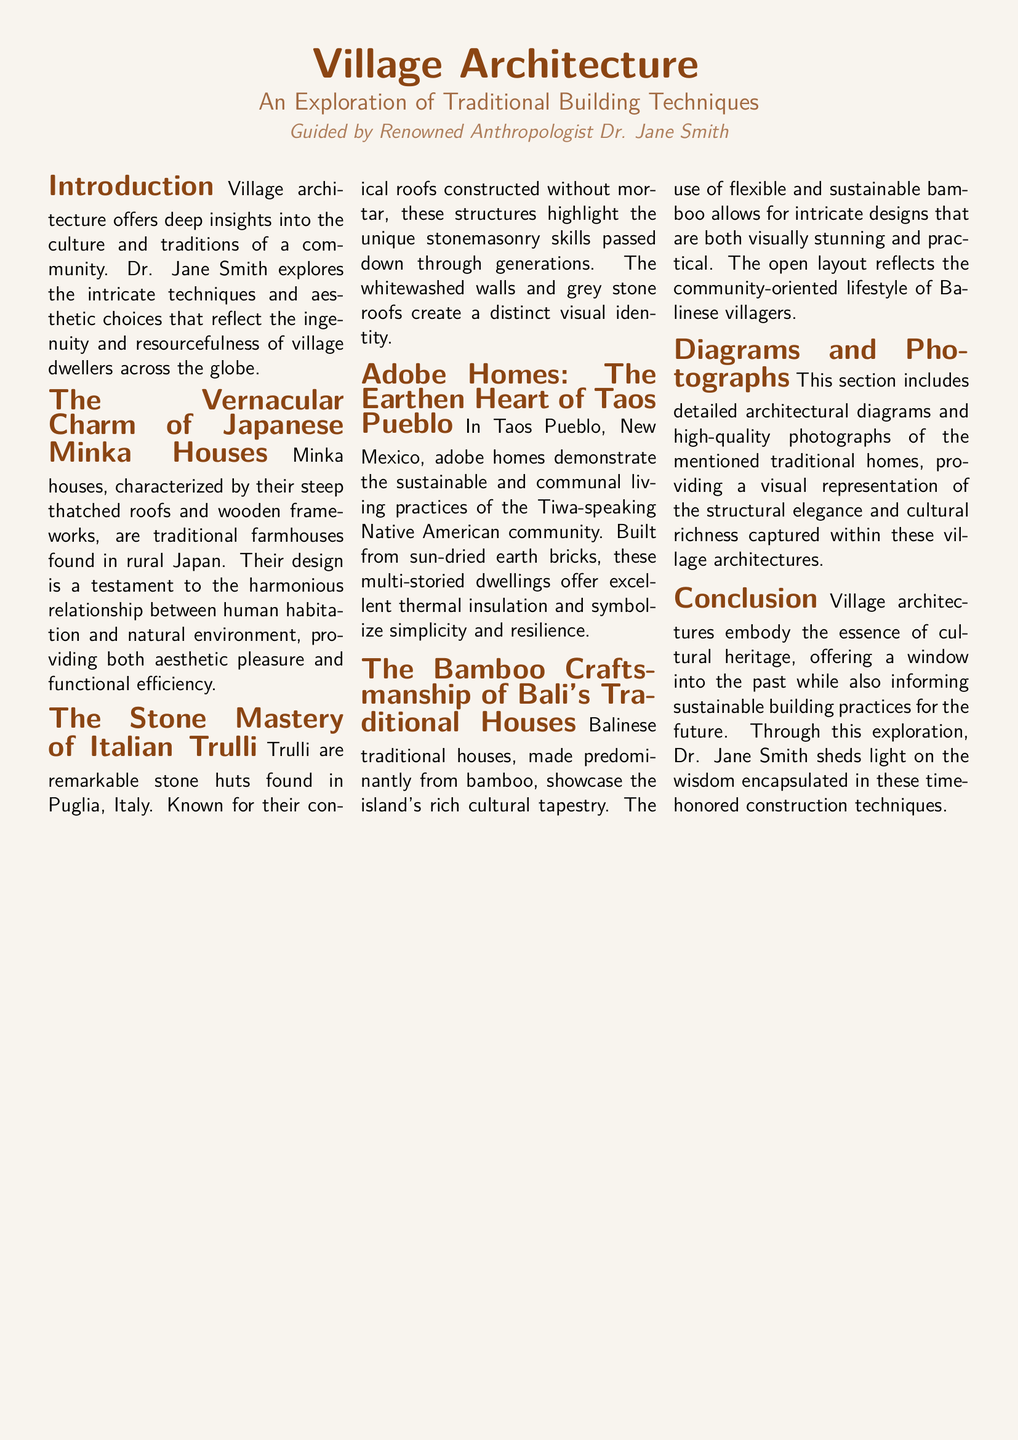What is the title of the document? The title appears prominently at the top of the document and is essential for identifying the content.
Answer: Village Architecture Who is the author guiding this exploration? The document attributes the work and insights to a specific person, crucial for understanding authorship.
Answer: Dr. Jane Smith What type of houses are characterized by steep thatched roofs in Japan? This description refers to a specific traditional house type mentioned in the document, indicating regional architecture.
Answer: Minka houses What is the primary building material used in Taos Pueblo homes? The document specifically mentions the material used in the construction of homes in this community, reflecting their building practices.
Answer: Adobe Which Italian architectural style features conical roofs? This is a specific architectural term based on the structures discussed in the document, highlighting regional characteristics.
Answer: Trulli How do Balinese traditional houses primarily reflect their cultural lifestyle? The document discusses the design and lifestyle connecting the community with their homes.
Answer: Community-oriented What is captured in the diagrams and photographs section? This section provides visual representation, important for understanding aesthetics and structural design conveyed in text.
Answer: Architectural diagrams and photographs What concept is highlighted in the conclusion related to cultural heritage? The conclusion synthesizes main themes discussed throughout the document, essential for final takeaways.
Answer: Sustainable building practices 